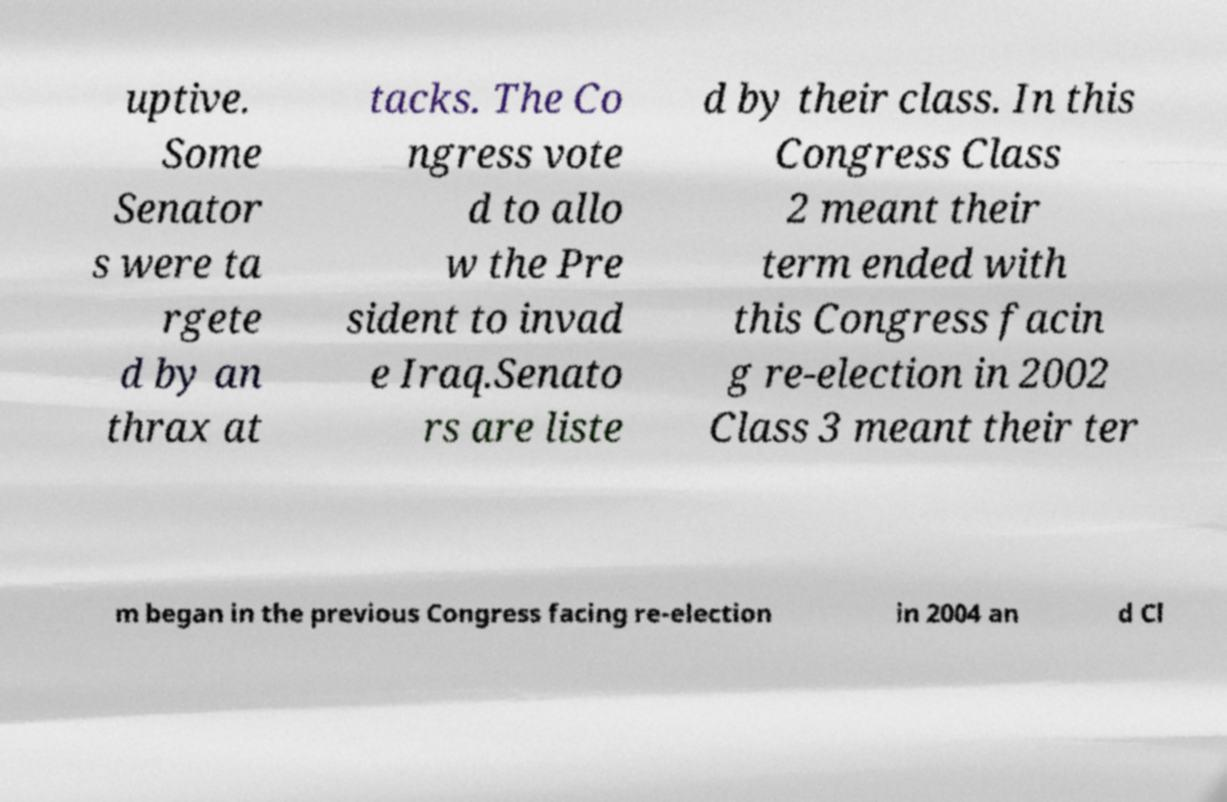Can you accurately transcribe the text from the provided image for me? uptive. Some Senator s were ta rgete d by an thrax at tacks. The Co ngress vote d to allo w the Pre sident to invad e Iraq.Senato rs are liste d by their class. In this Congress Class 2 meant their term ended with this Congress facin g re-election in 2002 Class 3 meant their ter m began in the previous Congress facing re-election in 2004 an d Cl 